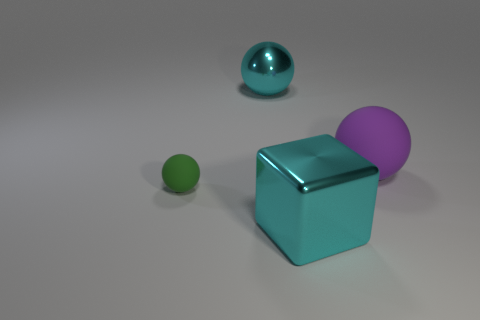Do the purple thing and the ball behind the large purple object have the same material?
Offer a terse response. No. The large shiny thing left of the cyan object on the right side of the shiny object that is behind the purple matte object is what color?
Your answer should be very brief. Cyan. There is a sphere that is the same size as the purple matte thing; what material is it?
Make the answer very short. Metal. How many tiny green balls are the same material as the big purple thing?
Your answer should be very brief. 1. There is a matte object to the right of the metallic sphere; is its size the same as the metallic thing that is on the right side of the big cyan ball?
Offer a very short reply. Yes. There is a big shiny thing that is in front of the big purple thing; what color is it?
Your answer should be compact. Cyan. What is the material of the object that is the same color as the big metal cube?
Give a very brief answer. Metal. What number of other shiny balls are the same color as the tiny ball?
Make the answer very short. 0. There is a purple matte object; does it have the same size as the thing that is in front of the small green rubber sphere?
Provide a succinct answer. Yes. There is a ball on the right side of the metal thing that is in front of the rubber ball that is right of the big cyan block; how big is it?
Ensure brevity in your answer.  Large. 